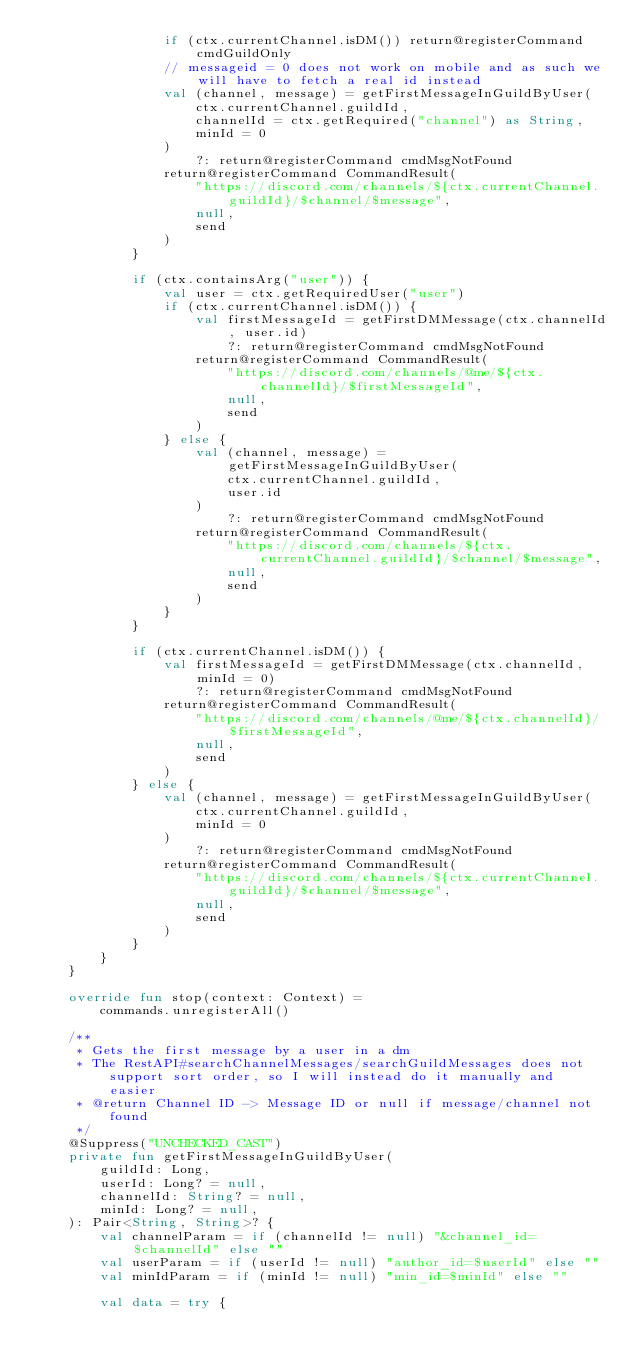<code> <loc_0><loc_0><loc_500><loc_500><_Kotlin_>				if (ctx.currentChannel.isDM()) return@registerCommand cmdGuildOnly
				// messageid = 0 does not work on mobile and as such we will have to fetch a real id instead
				val (channel, message) = getFirstMessageInGuildByUser(
					ctx.currentChannel.guildId,
					channelId = ctx.getRequired("channel") as String,
					minId = 0
				)
					?: return@registerCommand cmdMsgNotFound
				return@registerCommand CommandResult(
					"https://discord.com/channels/${ctx.currentChannel.guildId}/$channel/$message",
					null,
					send
				)
			}

			if (ctx.containsArg("user")) {
				val user = ctx.getRequiredUser("user")
				if (ctx.currentChannel.isDM()) {
					val firstMessageId = getFirstDMMessage(ctx.channelId, user.id)
						?: return@registerCommand cmdMsgNotFound
					return@registerCommand CommandResult(
						"https://discord.com/channels/@me/${ctx.channelId}/$firstMessageId",
						null,
						send
					)
				} else {
					val (channel, message) = getFirstMessageInGuildByUser(
						ctx.currentChannel.guildId,
						user.id
					)
						?: return@registerCommand cmdMsgNotFound
					return@registerCommand CommandResult(
						"https://discord.com/channels/${ctx.currentChannel.guildId}/$channel/$message",
						null,
						send
					)
				}
			}

			if (ctx.currentChannel.isDM()) {
				val firstMessageId = getFirstDMMessage(ctx.channelId, minId = 0)
					?: return@registerCommand cmdMsgNotFound
				return@registerCommand CommandResult(
					"https://discord.com/channels/@me/${ctx.channelId}/$firstMessageId",
					null,
					send
				)
			} else {
				val (channel, message) = getFirstMessageInGuildByUser(
					ctx.currentChannel.guildId,
					minId = 0
				)
					?: return@registerCommand cmdMsgNotFound
				return@registerCommand CommandResult(
					"https://discord.com/channels/${ctx.currentChannel.guildId}/$channel/$message",
					null,
					send
				)
			}
		}
	}

	override fun stop(context: Context) =
		commands.unregisterAll()

	/**
	 * Gets the first message by a user in a dm
	 * The RestAPI#searchChannelMessages/searchGuildMessages does not support sort order, so I will instead do it manually and easier
	 * @return Channel ID -> Message ID or null if message/channel not found
	 */
	@Suppress("UNCHECKED_CAST")
	private fun getFirstMessageInGuildByUser(
		guildId: Long,
		userId: Long? = null,
		channelId: String? = null,
		minId: Long? = null,
	): Pair<String, String>? {
		val channelParam = if (channelId != null) "&channel_id=$channelId" else ""
		val userParam = if (userId != null) "author_id=$userId" else ""
		val minIdParam = if (minId != null) "min_id=$minId" else ""

		val data = try {</code> 